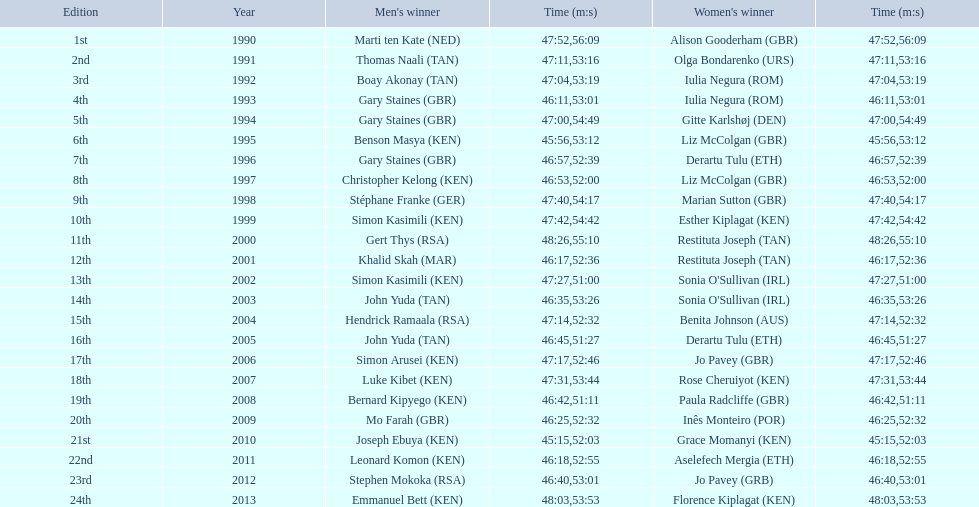The supplementary women's victor having the same end time as jo pavey in 201 Iulia Negura. 